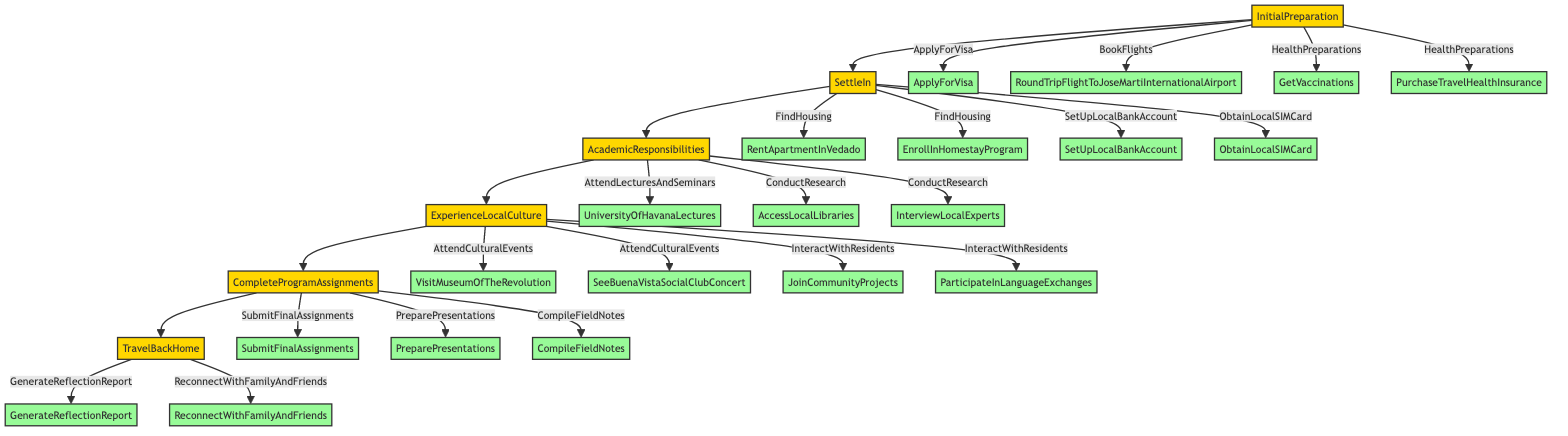What is the last step before traveling back home? The last step before reaching the "TravelBackHome" node is to complete the "CompleteProgramAssignments" node. This means you must finish and submit all necessary assignments.
Answer: Complete program assignments How many main phases are in the study abroad program? There are six main phases in total. They are "InitialPreparation," "SettleIn," "AcademicResponsibilities," "ExperienceLocalCulture," "CompleteProgramAssignments," and "TravelBackHome."
Answer: Six Which activity falls under "ExperienceLocalCulture"? One of the activities listed under "ExperienceLocalCulture" is "AttendCulturalEvents." Among these, you can visit the "MuseumOfTheRevolution" or attend a concert. Each of these activities shows local cultural experiences.
Answer: Attend cultural events What must be done before you can settle in? Before you can settle in, you need to complete the "InitialPreparation" phase. This includes applying for a visa, booking flights, and health preparations like vaccinations.
Answer: Initial preparation Which node comes directly after "SettleIn"? The node that comes directly after "SettleIn" in the flowchart is "AcademicResponsibilities." After settling in, you are expected to engage in your academic responsibilities.
Answer: Academic responsibilities What are the two options for finding housing? You have two options for finding housing listed under "SettleIn": you can either rent an apartment in Vedado or enroll in a homestay program.
Answer: Rent apartment in Vedado, enroll in homestay program What is required under "HealthPreparations"? Under "HealthPreparations," you need to get vaccinations and purchase travel health insurance. Both steps are essential for preparing for your travels.
Answer: Get vaccinations, purchase travel health insurance What happens after "CompleteProgramAssignments"? After completing the program assignments, you then proceed to the "TravelBackHome" phase, indicating that you’re ready to return home after completing all academic responsibilities.
Answer: Travel back home 